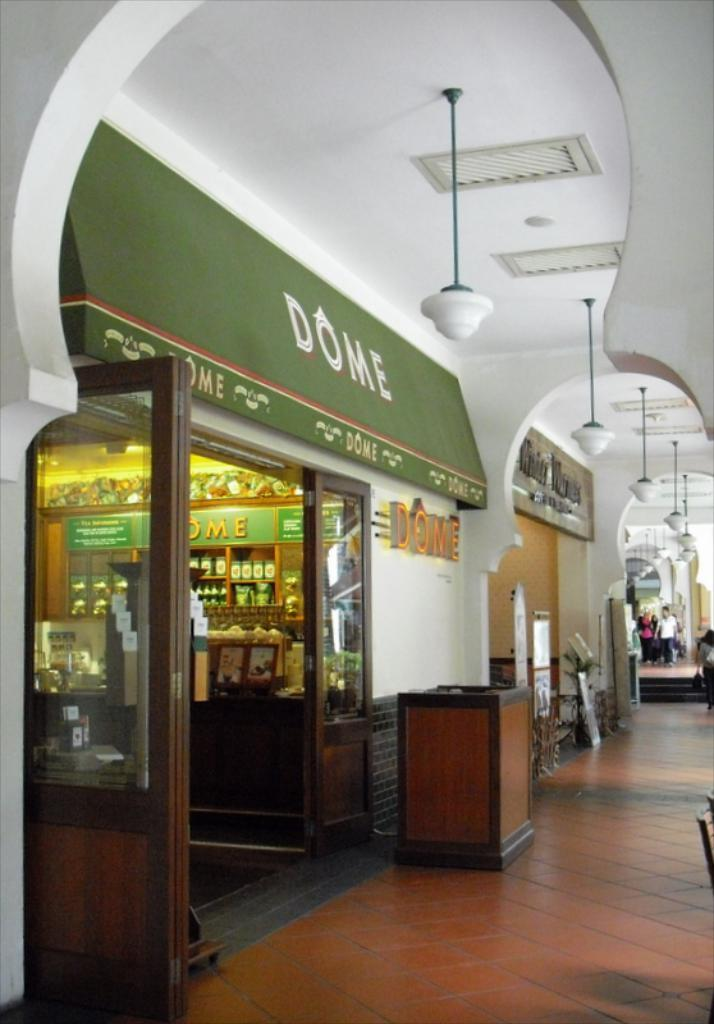<image>
Offer a succinct explanation of the picture presented. A photo of a store front of a store called Dome. 